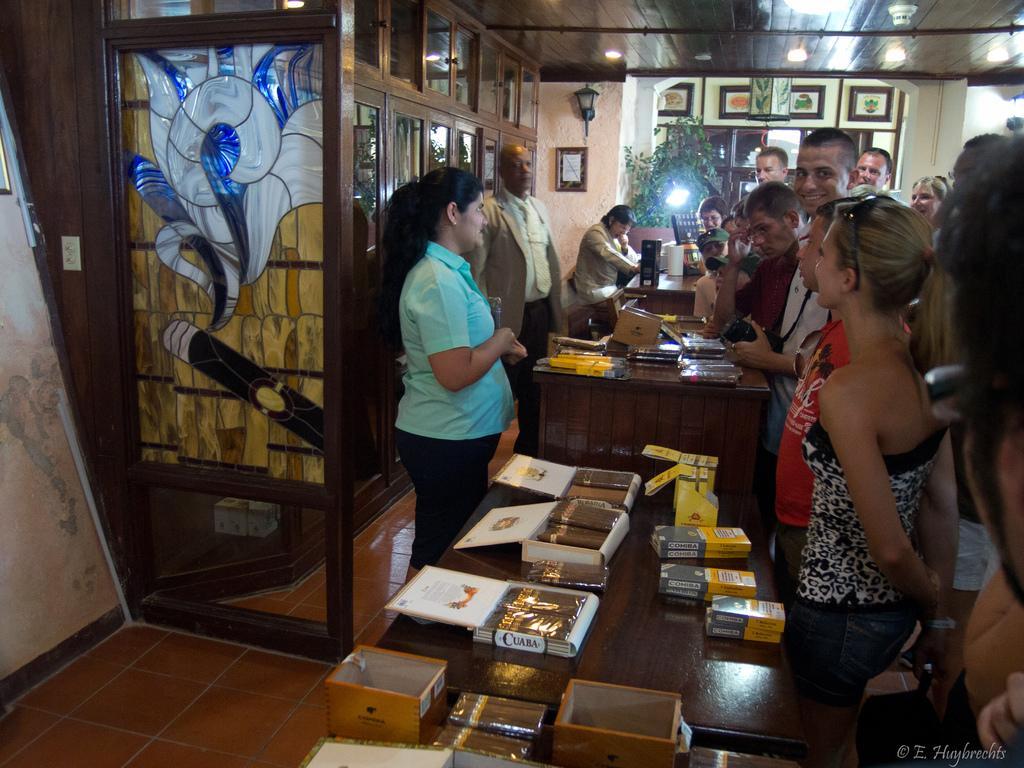Could you give a brief overview of what you see in this image? In this image there are people standing in front of the table. On top of the tables there are books, boxes and a few other objects. In the background of the image there are photo frames on the wall. There is a plant. On the left side of the image there are wooden cupboards. On top of the image there are lights. At the bottom of the image there is a floor. There is some text on the right side of the image. 